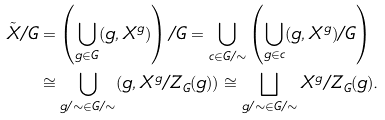Convert formula to latex. <formula><loc_0><loc_0><loc_500><loc_500>\tilde { X } / G & = \left ( \bigcup _ { g \in G } ( g , X ^ { g } ) \right ) / G = \bigcup _ { c \in G / \sim } \left ( \bigcup _ { g \in c } ( g , X ^ { g } ) / G \right ) \\ & \cong \bigcup _ { g / \sim \in G / \sim } ( g , X ^ { g } / Z _ { G } ( g ) ) \cong \bigsqcup _ { g / \sim \in G / \sim } X ^ { g } / Z _ { G } ( g ) .</formula> 